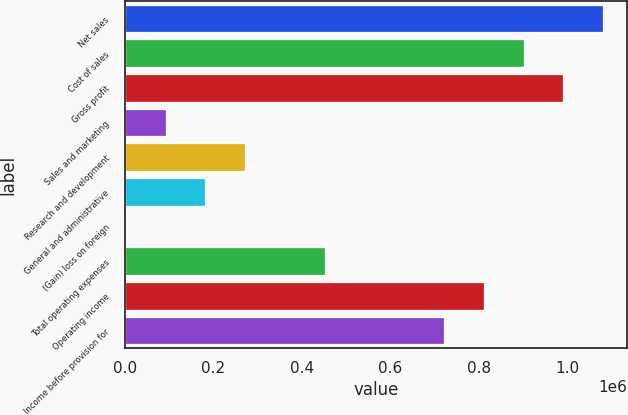<chart> <loc_0><loc_0><loc_500><loc_500><bar_chart><fcel>Net sales<fcel>Cost of sales<fcel>Gross profit<fcel>Sales and marketing<fcel>Research and development<fcel>General and administrative<fcel>(Gain) loss on foreign<fcel>Total operating expenses<fcel>Operating income<fcel>Income before provision for<nl><fcel>1.08101e+06<fcel>901265<fcel>991136<fcel>92430.5<fcel>272172<fcel>182301<fcel>2560<fcel>451912<fcel>811394<fcel>721524<nl></chart> 